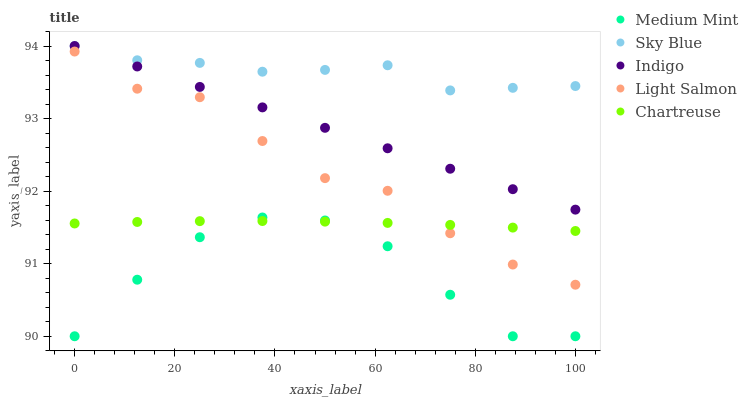Does Medium Mint have the minimum area under the curve?
Answer yes or no. Yes. Does Sky Blue have the maximum area under the curve?
Answer yes or no. Yes. Does Light Salmon have the minimum area under the curve?
Answer yes or no. No. Does Light Salmon have the maximum area under the curve?
Answer yes or no. No. Is Indigo the smoothest?
Answer yes or no. Yes. Is Medium Mint the roughest?
Answer yes or no. Yes. Is Sky Blue the smoothest?
Answer yes or no. No. Is Sky Blue the roughest?
Answer yes or no. No. Does Medium Mint have the lowest value?
Answer yes or no. Yes. Does Light Salmon have the lowest value?
Answer yes or no. No. Does Indigo have the highest value?
Answer yes or no. Yes. Does Light Salmon have the highest value?
Answer yes or no. No. Is Light Salmon less than Indigo?
Answer yes or no. Yes. Is Sky Blue greater than Chartreuse?
Answer yes or no. Yes. Does Chartreuse intersect Medium Mint?
Answer yes or no. Yes. Is Chartreuse less than Medium Mint?
Answer yes or no. No. Is Chartreuse greater than Medium Mint?
Answer yes or no. No. Does Light Salmon intersect Indigo?
Answer yes or no. No. 